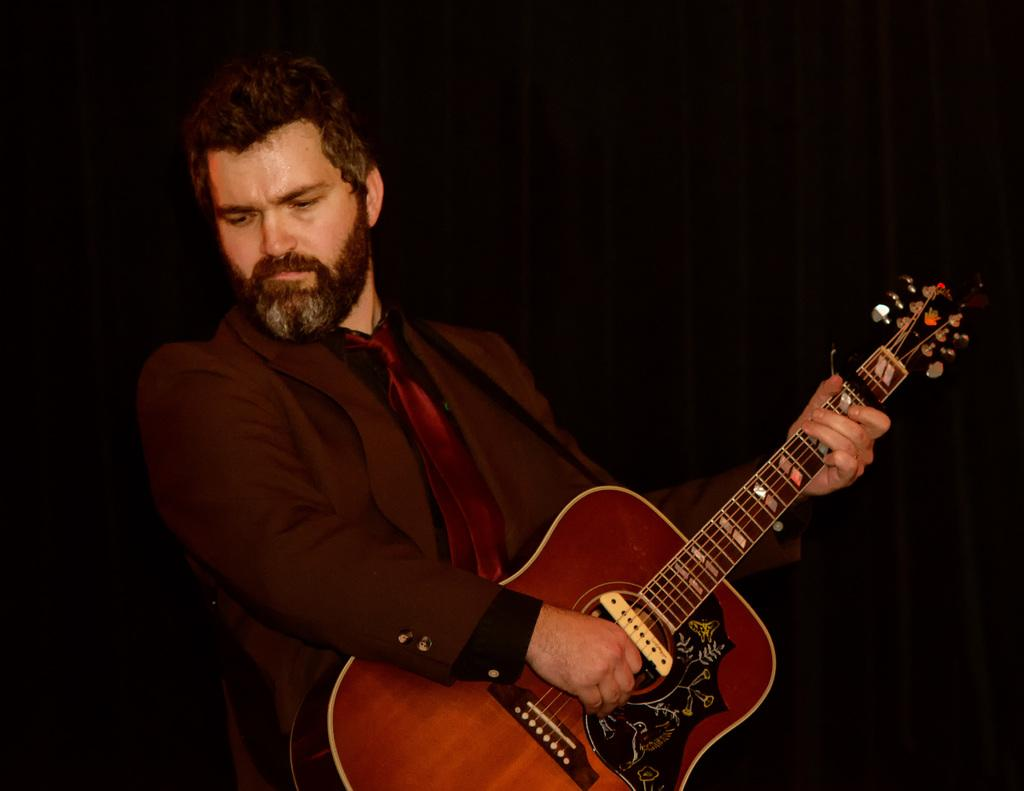What is the person in the image doing? The person is playing a guitar. How is the person dressed in the image? The person is wearing a suit and a tie. What is the person's posture in the image? The person is standing. How many cattle can be seen in the image? There are no cattle present in the image. What is the condition of the person's throat in the image? There is no information about the person's throat in the image. 